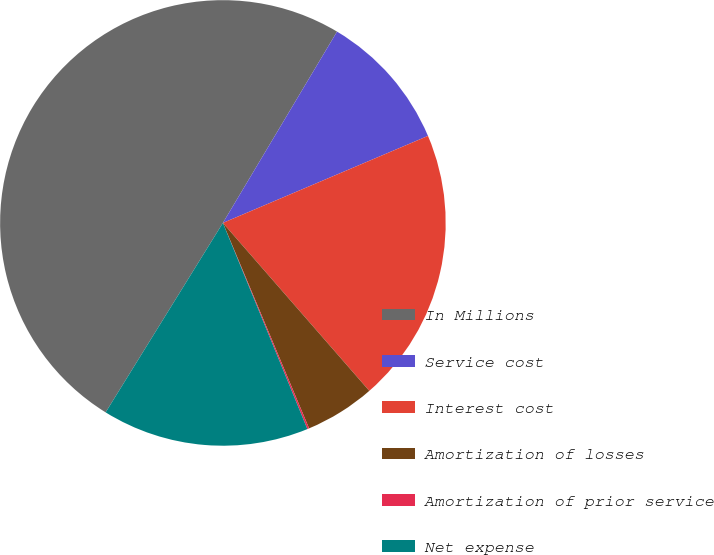<chart> <loc_0><loc_0><loc_500><loc_500><pie_chart><fcel>In Millions<fcel>Service cost<fcel>Interest cost<fcel>Amortization of losses<fcel>Amortization of prior service<fcel>Net expense<nl><fcel>49.73%<fcel>10.05%<fcel>19.97%<fcel>5.09%<fcel>0.13%<fcel>15.01%<nl></chart> 